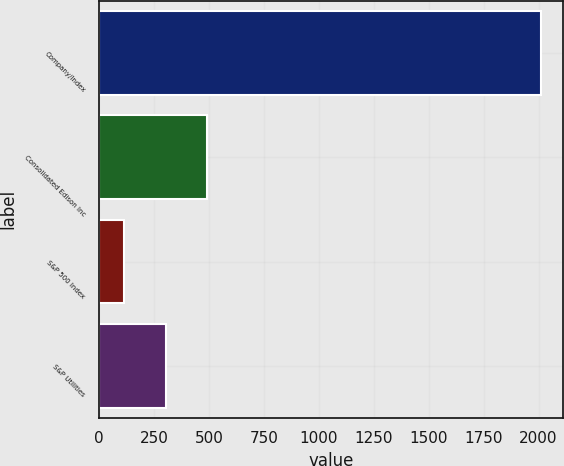Convert chart. <chart><loc_0><loc_0><loc_500><loc_500><bar_chart><fcel>Company/Index<fcel>Consolidated Edison Inc<fcel>S&P 500 Index<fcel>S&P Utilities<nl><fcel>2010<fcel>491.59<fcel>111.99<fcel>301.79<nl></chart> 